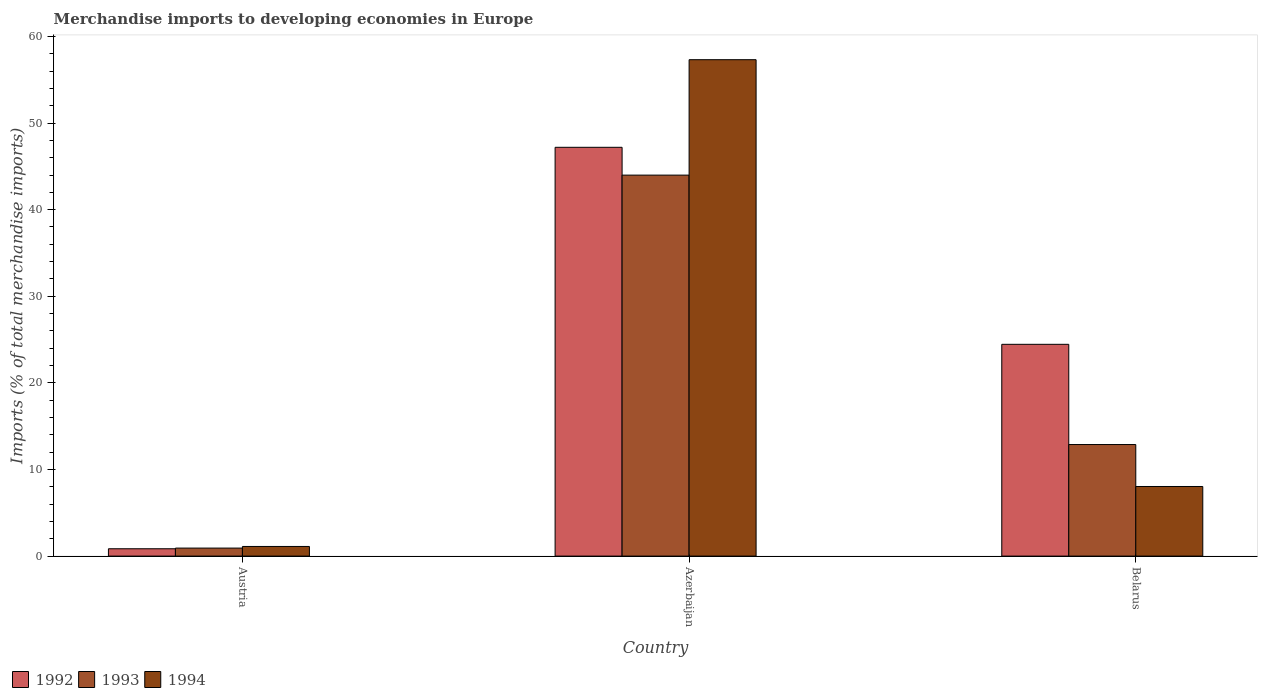How many different coloured bars are there?
Make the answer very short. 3. Are the number of bars per tick equal to the number of legend labels?
Your answer should be compact. Yes. How many bars are there on the 3rd tick from the left?
Offer a very short reply. 3. How many bars are there on the 1st tick from the right?
Give a very brief answer. 3. What is the label of the 2nd group of bars from the left?
Offer a terse response. Azerbaijan. In how many cases, is the number of bars for a given country not equal to the number of legend labels?
Provide a short and direct response. 0. What is the percentage total merchandise imports in 1992 in Azerbaijan?
Provide a short and direct response. 47.2. Across all countries, what is the maximum percentage total merchandise imports in 1993?
Make the answer very short. 43.99. Across all countries, what is the minimum percentage total merchandise imports in 1992?
Offer a very short reply. 0.85. In which country was the percentage total merchandise imports in 1993 maximum?
Make the answer very short. Azerbaijan. What is the total percentage total merchandise imports in 1992 in the graph?
Ensure brevity in your answer.  72.5. What is the difference between the percentage total merchandise imports in 1994 in Austria and that in Belarus?
Ensure brevity in your answer.  -6.92. What is the difference between the percentage total merchandise imports in 1993 in Azerbaijan and the percentage total merchandise imports in 1992 in Belarus?
Provide a short and direct response. 19.54. What is the average percentage total merchandise imports in 1994 per country?
Provide a short and direct response. 22.15. What is the difference between the percentage total merchandise imports of/in 1994 and percentage total merchandise imports of/in 1992 in Austria?
Your answer should be compact. 0.26. What is the ratio of the percentage total merchandise imports in 1992 in Austria to that in Azerbaijan?
Make the answer very short. 0.02. Is the percentage total merchandise imports in 1992 in Azerbaijan less than that in Belarus?
Your answer should be very brief. No. Is the difference between the percentage total merchandise imports in 1994 in Austria and Azerbaijan greater than the difference between the percentage total merchandise imports in 1992 in Austria and Azerbaijan?
Ensure brevity in your answer.  No. What is the difference between the highest and the second highest percentage total merchandise imports in 1994?
Give a very brief answer. -49.28. What is the difference between the highest and the lowest percentage total merchandise imports in 1992?
Your answer should be very brief. 46.35. In how many countries, is the percentage total merchandise imports in 1993 greater than the average percentage total merchandise imports in 1993 taken over all countries?
Offer a terse response. 1. What does the 1st bar from the left in Austria represents?
Ensure brevity in your answer.  1992. Is it the case that in every country, the sum of the percentage total merchandise imports in 1993 and percentage total merchandise imports in 1992 is greater than the percentage total merchandise imports in 1994?
Give a very brief answer. Yes. How many bars are there?
Your answer should be compact. 9. How many countries are there in the graph?
Make the answer very short. 3. What is the difference between two consecutive major ticks on the Y-axis?
Give a very brief answer. 10. Are the values on the major ticks of Y-axis written in scientific E-notation?
Offer a terse response. No. Does the graph contain any zero values?
Make the answer very short. No. Where does the legend appear in the graph?
Give a very brief answer. Bottom left. How many legend labels are there?
Keep it short and to the point. 3. What is the title of the graph?
Offer a very short reply. Merchandise imports to developing economies in Europe. What is the label or title of the Y-axis?
Your response must be concise. Imports (% of total merchandise imports). What is the Imports (% of total merchandise imports) of 1992 in Austria?
Provide a succinct answer. 0.85. What is the Imports (% of total merchandise imports) in 1993 in Austria?
Give a very brief answer. 0.93. What is the Imports (% of total merchandise imports) in 1994 in Austria?
Provide a succinct answer. 1.11. What is the Imports (% of total merchandise imports) in 1992 in Azerbaijan?
Keep it short and to the point. 47.2. What is the Imports (% of total merchandise imports) of 1993 in Azerbaijan?
Keep it short and to the point. 43.99. What is the Imports (% of total merchandise imports) of 1994 in Azerbaijan?
Provide a short and direct response. 57.31. What is the Imports (% of total merchandise imports) of 1992 in Belarus?
Ensure brevity in your answer.  24.45. What is the Imports (% of total merchandise imports) in 1993 in Belarus?
Give a very brief answer. 12.88. What is the Imports (% of total merchandise imports) in 1994 in Belarus?
Keep it short and to the point. 8.04. Across all countries, what is the maximum Imports (% of total merchandise imports) in 1992?
Make the answer very short. 47.2. Across all countries, what is the maximum Imports (% of total merchandise imports) of 1993?
Your answer should be compact. 43.99. Across all countries, what is the maximum Imports (% of total merchandise imports) of 1994?
Offer a very short reply. 57.31. Across all countries, what is the minimum Imports (% of total merchandise imports) of 1992?
Make the answer very short. 0.85. Across all countries, what is the minimum Imports (% of total merchandise imports) in 1993?
Ensure brevity in your answer.  0.93. Across all countries, what is the minimum Imports (% of total merchandise imports) in 1994?
Offer a terse response. 1.11. What is the total Imports (% of total merchandise imports) in 1992 in the graph?
Make the answer very short. 72.5. What is the total Imports (% of total merchandise imports) of 1993 in the graph?
Provide a short and direct response. 57.79. What is the total Imports (% of total merchandise imports) in 1994 in the graph?
Give a very brief answer. 66.46. What is the difference between the Imports (% of total merchandise imports) of 1992 in Austria and that in Azerbaijan?
Your answer should be compact. -46.35. What is the difference between the Imports (% of total merchandise imports) of 1993 in Austria and that in Azerbaijan?
Offer a very short reply. -43.06. What is the difference between the Imports (% of total merchandise imports) of 1994 in Austria and that in Azerbaijan?
Offer a terse response. -56.2. What is the difference between the Imports (% of total merchandise imports) of 1992 in Austria and that in Belarus?
Provide a succinct answer. -23.6. What is the difference between the Imports (% of total merchandise imports) in 1993 in Austria and that in Belarus?
Provide a succinct answer. -11.95. What is the difference between the Imports (% of total merchandise imports) of 1994 in Austria and that in Belarus?
Your answer should be compact. -6.92. What is the difference between the Imports (% of total merchandise imports) in 1992 in Azerbaijan and that in Belarus?
Ensure brevity in your answer.  22.75. What is the difference between the Imports (% of total merchandise imports) of 1993 in Azerbaijan and that in Belarus?
Make the answer very short. 31.11. What is the difference between the Imports (% of total merchandise imports) of 1994 in Azerbaijan and that in Belarus?
Offer a terse response. 49.28. What is the difference between the Imports (% of total merchandise imports) in 1992 in Austria and the Imports (% of total merchandise imports) in 1993 in Azerbaijan?
Make the answer very short. -43.14. What is the difference between the Imports (% of total merchandise imports) in 1992 in Austria and the Imports (% of total merchandise imports) in 1994 in Azerbaijan?
Your answer should be compact. -56.46. What is the difference between the Imports (% of total merchandise imports) in 1993 in Austria and the Imports (% of total merchandise imports) in 1994 in Azerbaijan?
Keep it short and to the point. -56.39. What is the difference between the Imports (% of total merchandise imports) of 1992 in Austria and the Imports (% of total merchandise imports) of 1993 in Belarus?
Your answer should be compact. -12.03. What is the difference between the Imports (% of total merchandise imports) of 1992 in Austria and the Imports (% of total merchandise imports) of 1994 in Belarus?
Your answer should be compact. -7.19. What is the difference between the Imports (% of total merchandise imports) of 1993 in Austria and the Imports (% of total merchandise imports) of 1994 in Belarus?
Offer a terse response. -7.11. What is the difference between the Imports (% of total merchandise imports) in 1992 in Azerbaijan and the Imports (% of total merchandise imports) in 1993 in Belarus?
Provide a short and direct response. 34.32. What is the difference between the Imports (% of total merchandise imports) in 1992 in Azerbaijan and the Imports (% of total merchandise imports) in 1994 in Belarus?
Ensure brevity in your answer.  39.16. What is the difference between the Imports (% of total merchandise imports) in 1993 in Azerbaijan and the Imports (% of total merchandise imports) in 1994 in Belarus?
Make the answer very short. 35.95. What is the average Imports (% of total merchandise imports) of 1992 per country?
Keep it short and to the point. 24.17. What is the average Imports (% of total merchandise imports) in 1993 per country?
Your answer should be compact. 19.26. What is the average Imports (% of total merchandise imports) in 1994 per country?
Offer a terse response. 22.15. What is the difference between the Imports (% of total merchandise imports) in 1992 and Imports (% of total merchandise imports) in 1993 in Austria?
Provide a succinct answer. -0.08. What is the difference between the Imports (% of total merchandise imports) of 1992 and Imports (% of total merchandise imports) of 1994 in Austria?
Keep it short and to the point. -0.26. What is the difference between the Imports (% of total merchandise imports) in 1993 and Imports (% of total merchandise imports) in 1994 in Austria?
Your response must be concise. -0.19. What is the difference between the Imports (% of total merchandise imports) of 1992 and Imports (% of total merchandise imports) of 1993 in Azerbaijan?
Provide a short and direct response. 3.21. What is the difference between the Imports (% of total merchandise imports) of 1992 and Imports (% of total merchandise imports) of 1994 in Azerbaijan?
Your answer should be compact. -10.11. What is the difference between the Imports (% of total merchandise imports) in 1993 and Imports (% of total merchandise imports) in 1994 in Azerbaijan?
Your answer should be compact. -13.33. What is the difference between the Imports (% of total merchandise imports) in 1992 and Imports (% of total merchandise imports) in 1993 in Belarus?
Provide a short and direct response. 11.57. What is the difference between the Imports (% of total merchandise imports) in 1992 and Imports (% of total merchandise imports) in 1994 in Belarus?
Offer a very short reply. 16.41. What is the difference between the Imports (% of total merchandise imports) in 1993 and Imports (% of total merchandise imports) in 1994 in Belarus?
Make the answer very short. 4.84. What is the ratio of the Imports (% of total merchandise imports) of 1992 in Austria to that in Azerbaijan?
Offer a terse response. 0.02. What is the ratio of the Imports (% of total merchandise imports) of 1993 in Austria to that in Azerbaijan?
Offer a very short reply. 0.02. What is the ratio of the Imports (% of total merchandise imports) in 1994 in Austria to that in Azerbaijan?
Your answer should be very brief. 0.02. What is the ratio of the Imports (% of total merchandise imports) of 1992 in Austria to that in Belarus?
Offer a terse response. 0.03. What is the ratio of the Imports (% of total merchandise imports) of 1993 in Austria to that in Belarus?
Your answer should be very brief. 0.07. What is the ratio of the Imports (% of total merchandise imports) of 1994 in Austria to that in Belarus?
Ensure brevity in your answer.  0.14. What is the ratio of the Imports (% of total merchandise imports) in 1992 in Azerbaijan to that in Belarus?
Keep it short and to the point. 1.93. What is the ratio of the Imports (% of total merchandise imports) of 1993 in Azerbaijan to that in Belarus?
Your answer should be compact. 3.42. What is the ratio of the Imports (% of total merchandise imports) of 1994 in Azerbaijan to that in Belarus?
Keep it short and to the point. 7.13. What is the difference between the highest and the second highest Imports (% of total merchandise imports) in 1992?
Your response must be concise. 22.75. What is the difference between the highest and the second highest Imports (% of total merchandise imports) of 1993?
Provide a succinct answer. 31.11. What is the difference between the highest and the second highest Imports (% of total merchandise imports) in 1994?
Your answer should be very brief. 49.28. What is the difference between the highest and the lowest Imports (% of total merchandise imports) of 1992?
Give a very brief answer. 46.35. What is the difference between the highest and the lowest Imports (% of total merchandise imports) in 1993?
Give a very brief answer. 43.06. What is the difference between the highest and the lowest Imports (% of total merchandise imports) in 1994?
Keep it short and to the point. 56.2. 